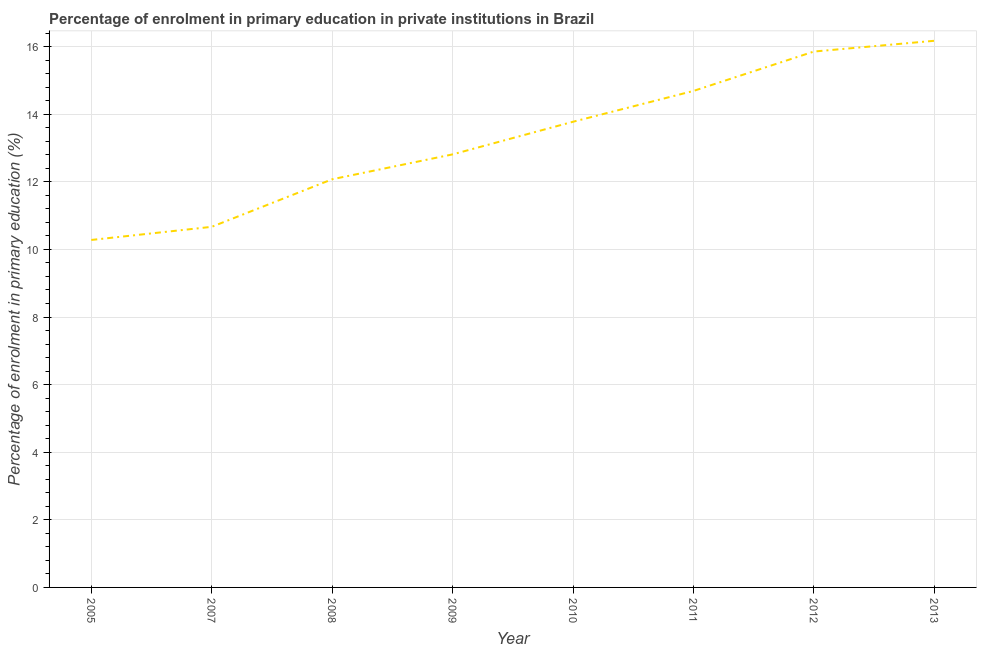What is the enrolment percentage in primary education in 2007?
Ensure brevity in your answer.  10.67. Across all years, what is the maximum enrolment percentage in primary education?
Give a very brief answer. 16.17. Across all years, what is the minimum enrolment percentage in primary education?
Your response must be concise. 10.28. In which year was the enrolment percentage in primary education minimum?
Offer a very short reply. 2005. What is the sum of the enrolment percentage in primary education?
Provide a short and direct response. 106.34. What is the difference between the enrolment percentage in primary education in 2008 and 2009?
Give a very brief answer. -0.74. What is the average enrolment percentage in primary education per year?
Provide a short and direct response. 13.29. What is the median enrolment percentage in primary education?
Your answer should be very brief. 13.3. What is the ratio of the enrolment percentage in primary education in 2009 to that in 2013?
Ensure brevity in your answer.  0.79. Is the enrolment percentage in primary education in 2009 less than that in 2013?
Offer a very short reply. Yes. Is the difference between the enrolment percentage in primary education in 2005 and 2010 greater than the difference between any two years?
Ensure brevity in your answer.  No. What is the difference between the highest and the second highest enrolment percentage in primary education?
Ensure brevity in your answer.  0.32. What is the difference between the highest and the lowest enrolment percentage in primary education?
Offer a very short reply. 5.89. How many lines are there?
Offer a very short reply. 1. What is the difference between two consecutive major ticks on the Y-axis?
Your answer should be very brief. 2. Does the graph contain any zero values?
Provide a short and direct response. No. Does the graph contain grids?
Your answer should be very brief. Yes. What is the title of the graph?
Offer a very short reply. Percentage of enrolment in primary education in private institutions in Brazil. What is the label or title of the Y-axis?
Your response must be concise. Percentage of enrolment in primary education (%). What is the Percentage of enrolment in primary education (%) of 2005?
Keep it short and to the point. 10.28. What is the Percentage of enrolment in primary education (%) in 2007?
Your answer should be compact. 10.67. What is the Percentage of enrolment in primary education (%) of 2008?
Your response must be concise. 12.08. What is the Percentage of enrolment in primary education (%) of 2009?
Make the answer very short. 12.81. What is the Percentage of enrolment in primary education (%) of 2010?
Offer a very short reply. 13.78. What is the Percentage of enrolment in primary education (%) in 2011?
Keep it short and to the point. 14.69. What is the Percentage of enrolment in primary education (%) in 2012?
Make the answer very short. 15.86. What is the Percentage of enrolment in primary education (%) in 2013?
Your response must be concise. 16.17. What is the difference between the Percentage of enrolment in primary education (%) in 2005 and 2007?
Keep it short and to the point. -0.39. What is the difference between the Percentage of enrolment in primary education (%) in 2005 and 2008?
Your response must be concise. -1.8. What is the difference between the Percentage of enrolment in primary education (%) in 2005 and 2009?
Provide a short and direct response. -2.53. What is the difference between the Percentage of enrolment in primary education (%) in 2005 and 2010?
Provide a succinct answer. -3.5. What is the difference between the Percentage of enrolment in primary education (%) in 2005 and 2011?
Keep it short and to the point. -4.41. What is the difference between the Percentage of enrolment in primary education (%) in 2005 and 2012?
Your answer should be compact. -5.57. What is the difference between the Percentage of enrolment in primary education (%) in 2005 and 2013?
Make the answer very short. -5.89. What is the difference between the Percentage of enrolment in primary education (%) in 2007 and 2008?
Provide a succinct answer. -1.41. What is the difference between the Percentage of enrolment in primary education (%) in 2007 and 2009?
Your answer should be compact. -2.14. What is the difference between the Percentage of enrolment in primary education (%) in 2007 and 2010?
Offer a terse response. -3.11. What is the difference between the Percentage of enrolment in primary education (%) in 2007 and 2011?
Your answer should be very brief. -4.02. What is the difference between the Percentage of enrolment in primary education (%) in 2007 and 2012?
Make the answer very short. -5.19. What is the difference between the Percentage of enrolment in primary education (%) in 2007 and 2013?
Make the answer very short. -5.5. What is the difference between the Percentage of enrolment in primary education (%) in 2008 and 2009?
Your answer should be compact. -0.74. What is the difference between the Percentage of enrolment in primary education (%) in 2008 and 2010?
Ensure brevity in your answer.  -1.7. What is the difference between the Percentage of enrolment in primary education (%) in 2008 and 2011?
Your response must be concise. -2.61. What is the difference between the Percentage of enrolment in primary education (%) in 2008 and 2012?
Give a very brief answer. -3.78. What is the difference between the Percentage of enrolment in primary education (%) in 2008 and 2013?
Make the answer very short. -4.1. What is the difference between the Percentage of enrolment in primary education (%) in 2009 and 2010?
Your response must be concise. -0.97. What is the difference between the Percentage of enrolment in primary education (%) in 2009 and 2011?
Your response must be concise. -1.88. What is the difference between the Percentage of enrolment in primary education (%) in 2009 and 2012?
Your answer should be very brief. -3.04. What is the difference between the Percentage of enrolment in primary education (%) in 2009 and 2013?
Offer a very short reply. -3.36. What is the difference between the Percentage of enrolment in primary education (%) in 2010 and 2011?
Ensure brevity in your answer.  -0.91. What is the difference between the Percentage of enrolment in primary education (%) in 2010 and 2012?
Give a very brief answer. -2.08. What is the difference between the Percentage of enrolment in primary education (%) in 2010 and 2013?
Offer a very short reply. -2.4. What is the difference between the Percentage of enrolment in primary education (%) in 2011 and 2012?
Your answer should be compact. -1.17. What is the difference between the Percentage of enrolment in primary education (%) in 2011 and 2013?
Provide a short and direct response. -1.48. What is the difference between the Percentage of enrolment in primary education (%) in 2012 and 2013?
Ensure brevity in your answer.  -0.32. What is the ratio of the Percentage of enrolment in primary education (%) in 2005 to that in 2008?
Your response must be concise. 0.85. What is the ratio of the Percentage of enrolment in primary education (%) in 2005 to that in 2009?
Keep it short and to the point. 0.8. What is the ratio of the Percentage of enrolment in primary education (%) in 2005 to that in 2010?
Your answer should be compact. 0.75. What is the ratio of the Percentage of enrolment in primary education (%) in 2005 to that in 2011?
Offer a very short reply. 0.7. What is the ratio of the Percentage of enrolment in primary education (%) in 2005 to that in 2012?
Offer a very short reply. 0.65. What is the ratio of the Percentage of enrolment in primary education (%) in 2005 to that in 2013?
Your answer should be very brief. 0.64. What is the ratio of the Percentage of enrolment in primary education (%) in 2007 to that in 2008?
Offer a terse response. 0.88. What is the ratio of the Percentage of enrolment in primary education (%) in 2007 to that in 2009?
Keep it short and to the point. 0.83. What is the ratio of the Percentage of enrolment in primary education (%) in 2007 to that in 2010?
Offer a terse response. 0.77. What is the ratio of the Percentage of enrolment in primary education (%) in 2007 to that in 2011?
Provide a short and direct response. 0.73. What is the ratio of the Percentage of enrolment in primary education (%) in 2007 to that in 2012?
Ensure brevity in your answer.  0.67. What is the ratio of the Percentage of enrolment in primary education (%) in 2007 to that in 2013?
Provide a succinct answer. 0.66. What is the ratio of the Percentage of enrolment in primary education (%) in 2008 to that in 2009?
Ensure brevity in your answer.  0.94. What is the ratio of the Percentage of enrolment in primary education (%) in 2008 to that in 2010?
Offer a very short reply. 0.88. What is the ratio of the Percentage of enrolment in primary education (%) in 2008 to that in 2011?
Ensure brevity in your answer.  0.82. What is the ratio of the Percentage of enrolment in primary education (%) in 2008 to that in 2012?
Your answer should be compact. 0.76. What is the ratio of the Percentage of enrolment in primary education (%) in 2008 to that in 2013?
Provide a short and direct response. 0.75. What is the ratio of the Percentage of enrolment in primary education (%) in 2009 to that in 2010?
Your answer should be compact. 0.93. What is the ratio of the Percentage of enrolment in primary education (%) in 2009 to that in 2011?
Your answer should be compact. 0.87. What is the ratio of the Percentage of enrolment in primary education (%) in 2009 to that in 2012?
Your response must be concise. 0.81. What is the ratio of the Percentage of enrolment in primary education (%) in 2009 to that in 2013?
Ensure brevity in your answer.  0.79. What is the ratio of the Percentage of enrolment in primary education (%) in 2010 to that in 2011?
Give a very brief answer. 0.94. What is the ratio of the Percentage of enrolment in primary education (%) in 2010 to that in 2012?
Provide a succinct answer. 0.87. What is the ratio of the Percentage of enrolment in primary education (%) in 2010 to that in 2013?
Offer a terse response. 0.85. What is the ratio of the Percentage of enrolment in primary education (%) in 2011 to that in 2012?
Your answer should be compact. 0.93. What is the ratio of the Percentage of enrolment in primary education (%) in 2011 to that in 2013?
Keep it short and to the point. 0.91. 